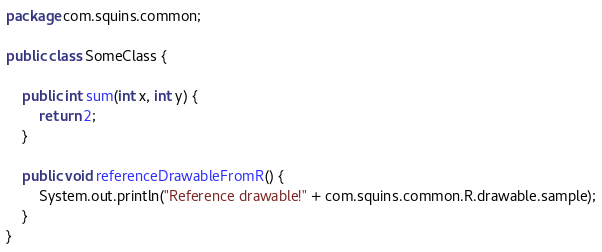<code> <loc_0><loc_0><loc_500><loc_500><_Java_>package com.squins.common;

public class SomeClass {

    public int sum(int x, int y) {
        return 2;
    }
    
    public void referenceDrawableFromR() {
        System.out.println("Reference drawable!" + com.squins.common.R.drawable.sample);
    }
}
</code> 